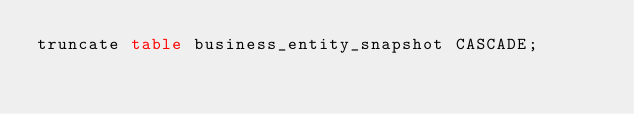<code> <loc_0><loc_0><loc_500><loc_500><_SQL_>truncate table business_entity_snapshot CASCADE;


</code> 